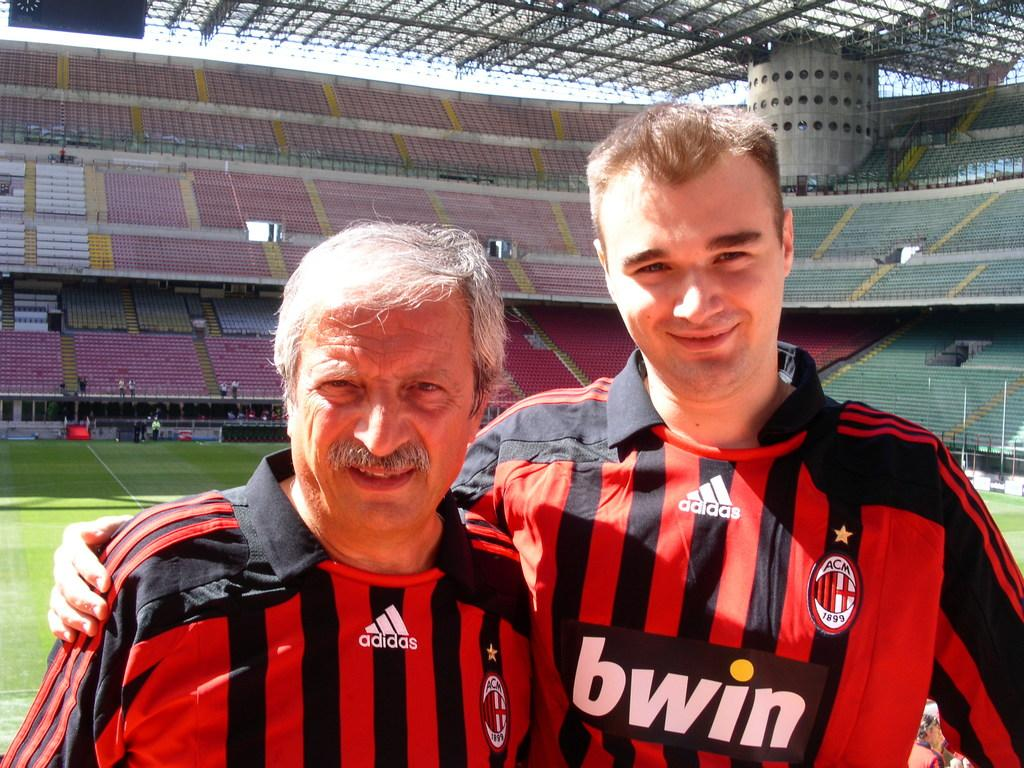<image>
Provide a brief description of the given image. A man in a shirt that says Bwin on the front stands with his arm around another man. 